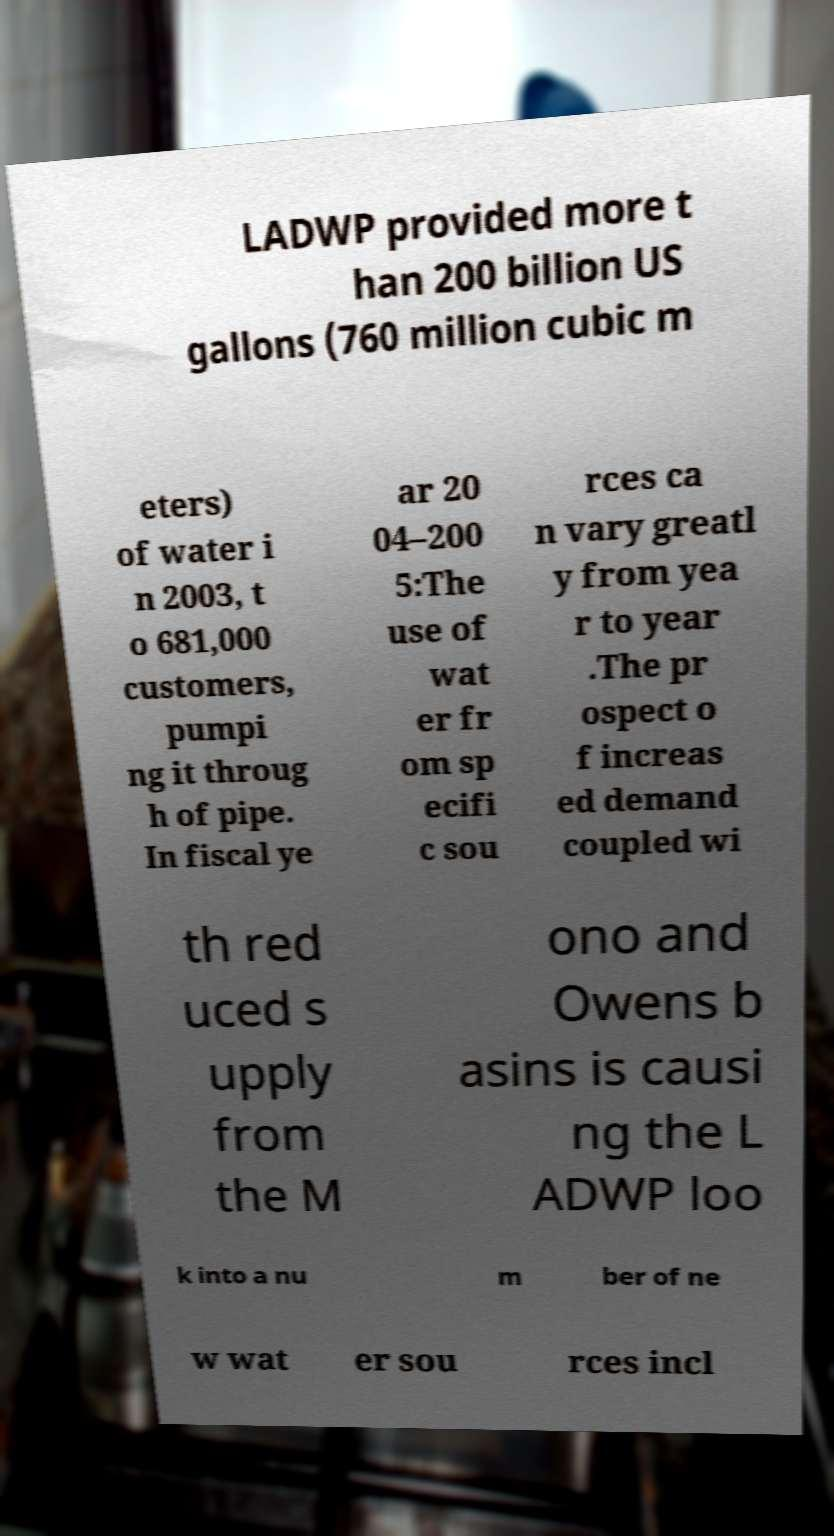There's text embedded in this image that I need extracted. Can you transcribe it verbatim? LADWP provided more t han 200 billion US gallons (760 million cubic m eters) of water i n 2003, t o 681,000 customers, pumpi ng it throug h of pipe. In fiscal ye ar 20 04–200 5:The use of wat er fr om sp ecifi c sou rces ca n vary greatl y from yea r to year .The pr ospect o f increas ed demand coupled wi th red uced s upply from the M ono and Owens b asins is causi ng the L ADWP loo k into a nu m ber of ne w wat er sou rces incl 